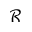Convert formula to latex. <formula><loc_0><loc_0><loc_500><loc_500>\mathcal { R }</formula> 